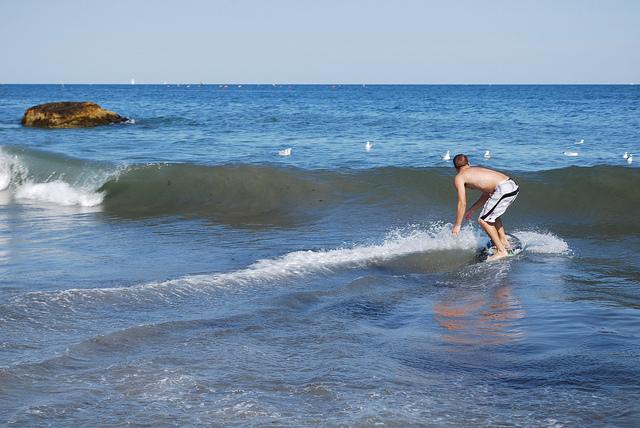What else is in the water?
Concise answer only. Rock. Is there a wave?
Concise answer only. Yes. What is this person doing?
Concise answer only. Surfing. How many people are pictured?
Give a very brief answer. 1. Is the man wearing safety gear?
Answer briefly. No. How many people in the pool?
Keep it brief. 1. 